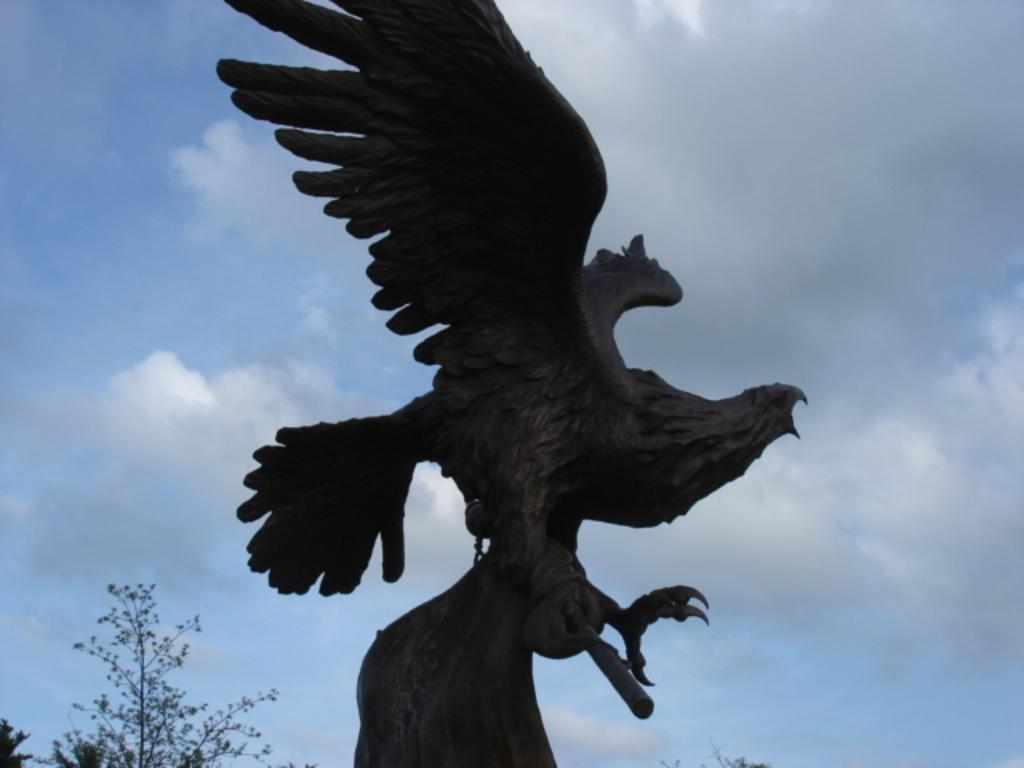What is the main subject of the image? There is a statue of a bird in the image. What type of natural elements can be seen in the image? There are trees in the image. What is visible in the background of the image? The sky is visible in the background of the image. What can be observed in the sky? Clouds are present in the sky. Where is the prison located in the image? There is no prison present in the image. What type of honey can be seen dripping from the statue of the bird? There is no honey present in the image, and the statue of the bird is not depicted as dripping anything. 